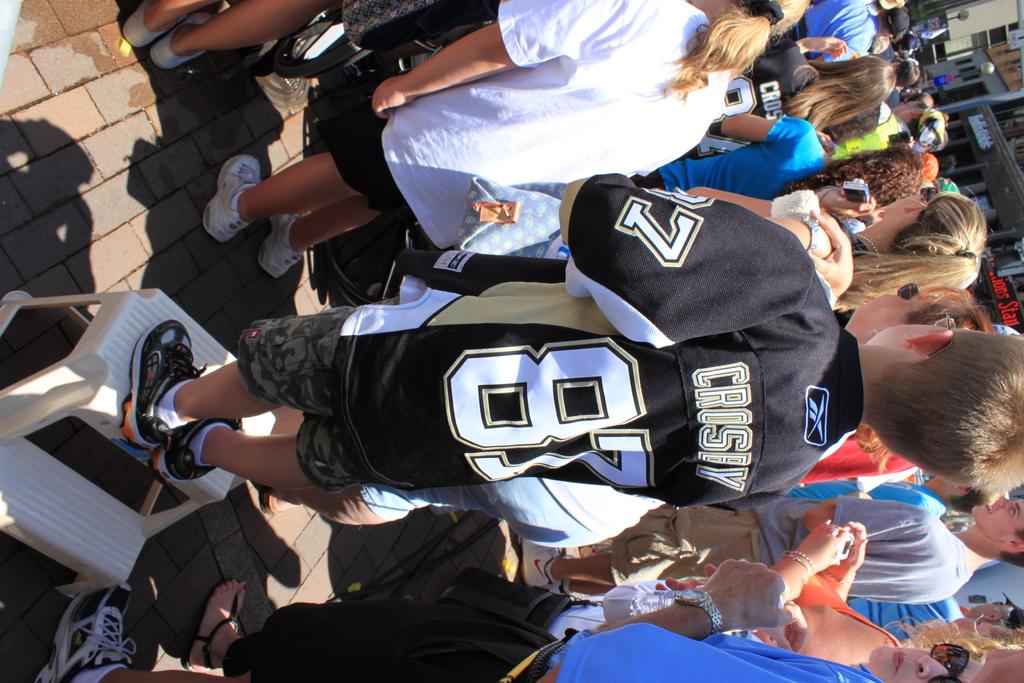What is the number on the back of the jersey?
Offer a very short reply. 87. 